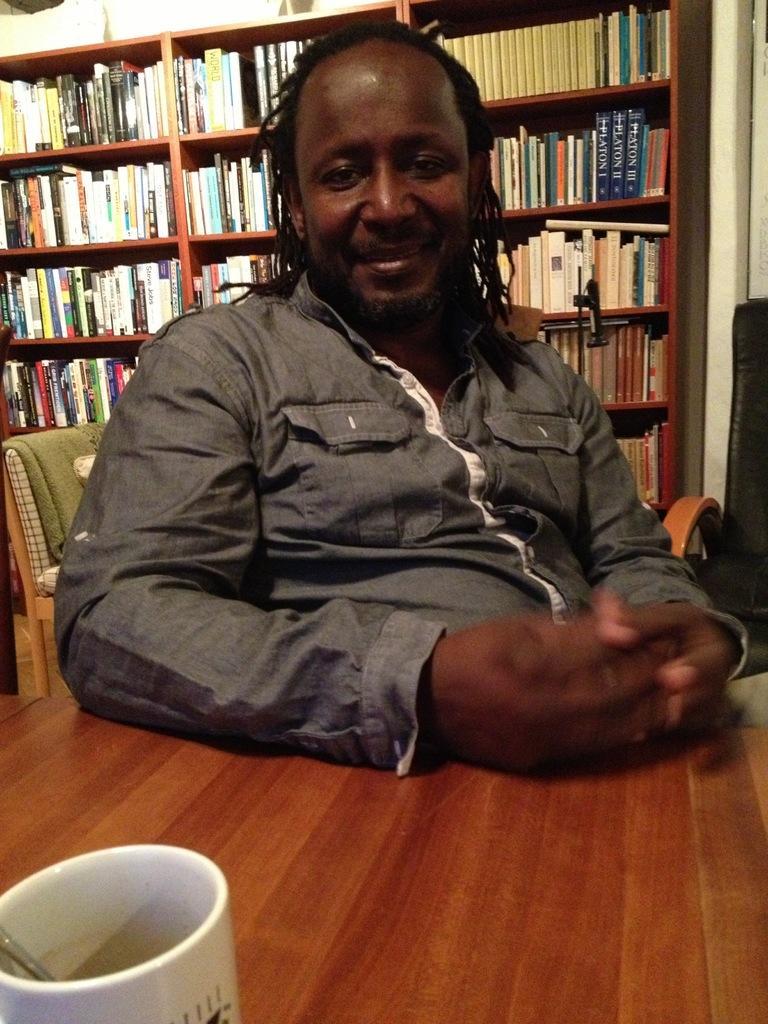Please provide a concise description of this image. In the picture we can see a man sitting on a chair near the table and we can see a cup on the table, in the background we can see a rack with books in it and one chair just beside it. A man is wearing a shirt which is ash in color and a long hair. 